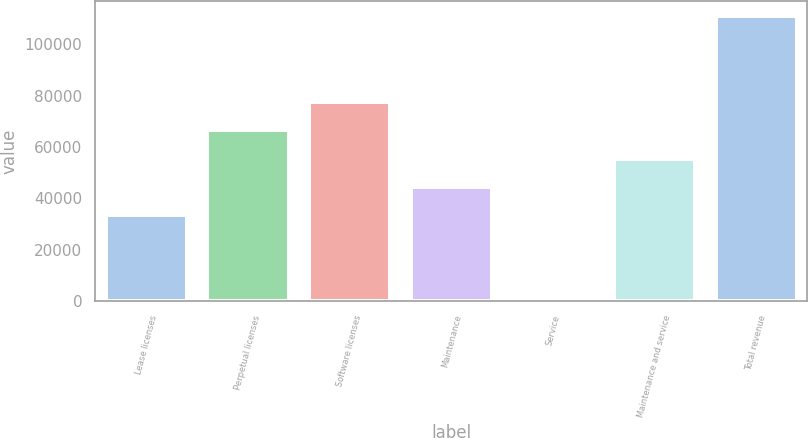Convert chart to OTSL. <chart><loc_0><loc_0><loc_500><loc_500><bar_chart><fcel>Lease licenses<fcel>Perpetual licenses<fcel>Software licenses<fcel>Maintenance<fcel>Service<fcel>Maintenance and service<fcel>Total revenue<nl><fcel>33466<fcel>66444.7<fcel>77437.6<fcel>44458.9<fcel>1284<fcel>55451.8<fcel>111213<nl></chart> 